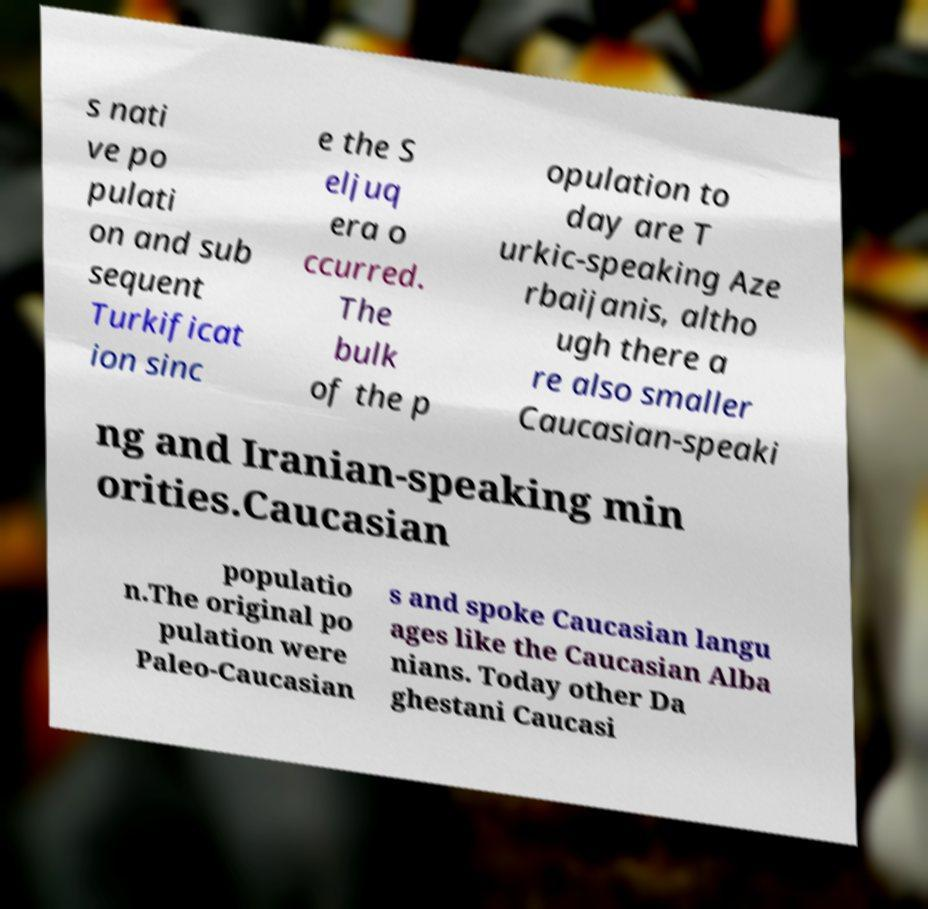For documentation purposes, I need the text within this image transcribed. Could you provide that? s nati ve po pulati on and sub sequent Turkificat ion sinc e the S eljuq era o ccurred. The bulk of the p opulation to day are T urkic-speaking Aze rbaijanis, altho ugh there a re also smaller Caucasian-speaki ng and Iranian-speaking min orities.Caucasian populatio n.The original po pulation were Paleo-Caucasian s and spoke Caucasian langu ages like the Caucasian Alba nians. Today other Da ghestani Caucasi 